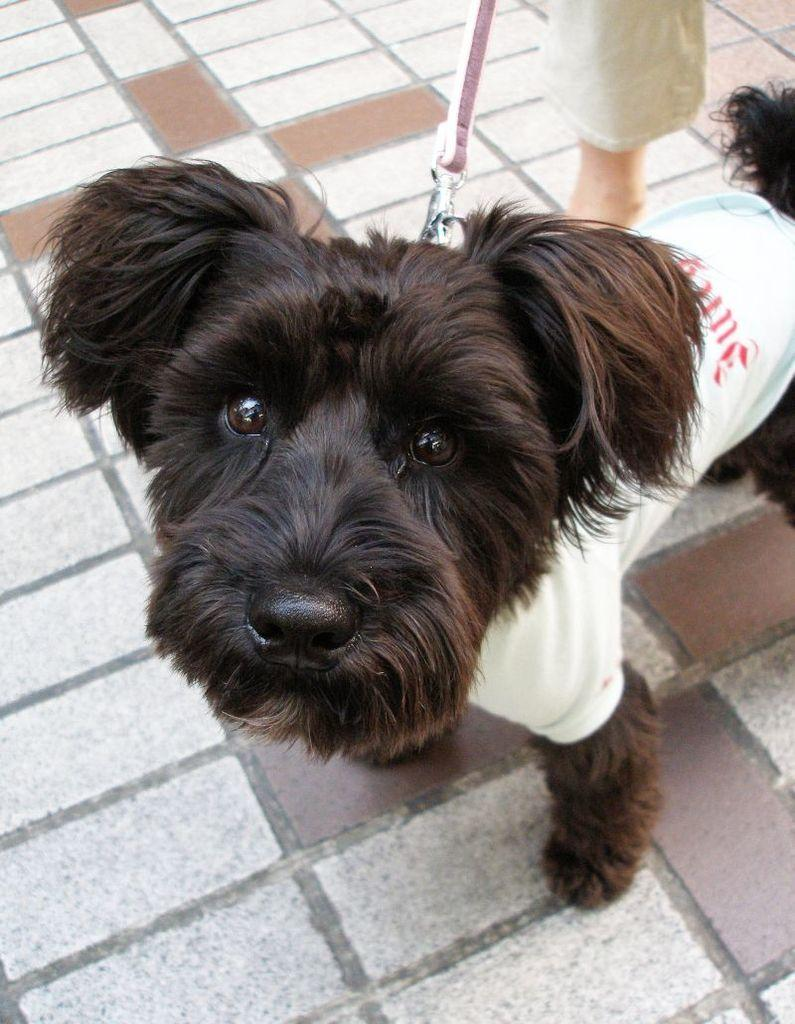What type of animal is in the image? There is a fluffy dog in the image. How is the dog being controlled or restrained? The dog has a chain tied around its neck, and a person is holding the chain. Where are the dog and the person standing? Both the dog and the person are standing on a pavement. What type of wound can be seen on the dog's paw in the image? There is no wound visible on the dog's paw in the image. What kind of twig is the dog chewing on in the image? There is no twig present in the image; the dog has a chain tied around its neck. 